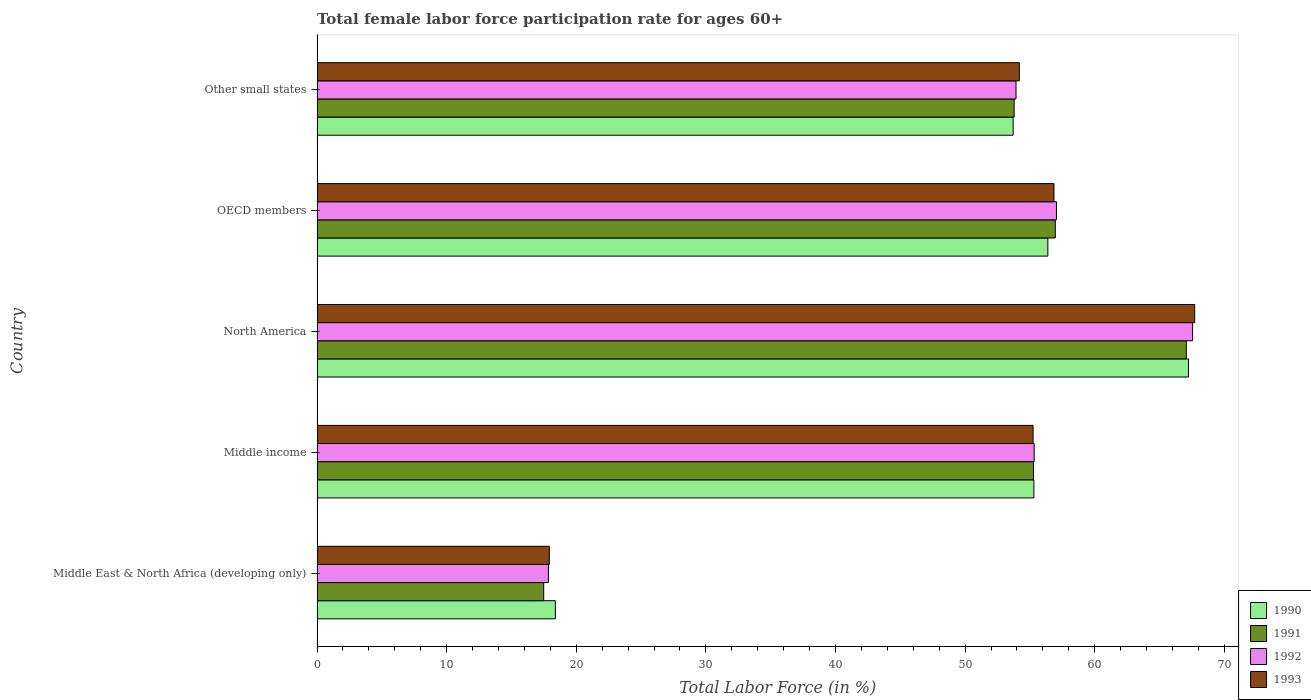How many groups of bars are there?
Keep it short and to the point. 5. How many bars are there on the 4th tick from the bottom?
Offer a terse response. 4. What is the label of the 4th group of bars from the top?
Make the answer very short. Middle income. In how many cases, is the number of bars for a given country not equal to the number of legend labels?
Give a very brief answer. 0. What is the female labor force participation rate in 1992 in Middle East & North Africa (developing only)?
Make the answer very short. 17.85. Across all countries, what is the maximum female labor force participation rate in 1990?
Provide a succinct answer. 67.23. Across all countries, what is the minimum female labor force participation rate in 1992?
Provide a succinct answer. 17.85. In which country was the female labor force participation rate in 1992 minimum?
Ensure brevity in your answer.  Middle East & North Africa (developing only). What is the total female labor force participation rate in 1991 in the graph?
Make the answer very short. 250.57. What is the difference between the female labor force participation rate in 1993 in Middle income and that in OECD members?
Your answer should be very brief. -1.61. What is the difference between the female labor force participation rate in 1991 in Middle income and the female labor force participation rate in 1990 in Middle East & North Africa (developing only)?
Your response must be concise. 36.89. What is the average female labor force participation rate in 1992 per country?
Ensure brevity in your answer.  50.34. What is the difference between the female labor force participation rate in 1990 and female labor force participation rate in 1992 in Other small states?
Your response must be concise. -0.22. In how many countries, is the female labor force participation rate in 1990 greater than 64 %?
Your response must be concise. 1. What is the ratio of the female labor force participation rate in 1993 in Middle East & North Africa (developing only) to that in Middle income?
Offer a terse response. 0.32. Is the difference between the female labor force participation rate in 1990 in Middle East & North Africa (developing only) and OECD members greater than the difference between the female labor force participation rate in 1992 in Middle East & North Africa (developing only) and OECD members?
Make the answer very short. Yes. What is the difference between the highest and the second highest female labor force participation rate in 1990?
Give a very brief answer. 10.85. What is the difference between the highest and the lowest female labor force participation rate in 1990?
Your answer should be compact. 48.85. Is the sum of the female labor force participation rate in 1990 in Middle East & North Africa (developing only) and North America greater than the maximum female labor force participation rate in 1992 across all countries?
Provide a succinct answer. Yes. What does the 1st bar from the top in Middle East & North Africa (developing only) represents?
Offer a terse response. 1993. How many countries are there in the graph?
Provide a succinct answer. 5. What is the difference between two consecutive major ticks on the X-axis?
Provide a short and direct response. 10. Does the graph contain grids?
Your response must be concise. No. Where does the legend appear in the graph?
Your response must be concise. Bottom right. How many legend labels are there?
Provide a short and direct response. 4. What is the title of the graph?
Give a very brief answer. Total female labor force participation rate for ages 60+. Does "1990" appear as one of the legend labels in the graph?
Ensure brevity in your answer.  Yes. What is the label or title of the X-axis?
Your answer should be compact. Total Labor Force (in %). What is the label or title of the Y-axis?
Your answer should be compact. Country. What is the Total Labor Force (in %) in 1990 in Middle East & North Africa (developing only)?
Ensure brevity in your answer.  18.39. What is the Total Labor Force (in %) of 1991 in Middle East & North Africa (developing only)?
Give a very brief answer. 17.49. What is the Total Labor Force (in %) of 1992 in Middle East & North Africa (developing only)?
Your response must be concise. 17.85. What is the Total Labor Force (in %) in 1993 in Middle East & North Africa (developing only)?
Provide a short and direct response. 17.92. What is the Total Labor Force (in %) in 1990 in Middle income?
Provide a short and direct response. 55.31. What is the Total Labor Force (in %) of 1991 in Middle income?
Give a very brief answer. 55.28. What is the Total Labor Force (in %) in 1992 in Middle income?
Offer a very short reply. 55.33. What is the Total Labor Force (in %) of 1993 in Middle income?
Your answer should be very brief. 55.24. What is the Total Labor Force (in %) in 1990 in North America?
Ensure brevity in your answer.  67.23. What is the Total Labor Force (in %) in 1991 in North America?
Your answer should be very brief. 67.06. What is the Total Labor Force (in %) of 1992 in North America?
Your response must be concise. 67.55. What is the Total Labor Force (in %) of 1993 in North America?
Offer a terse response. 67.71. What is the Total Labor Force (in %) of 1990 in OECD members?
Offer a terse response. 56.38. What is the Total Labor Force (in %) in 1991 in OECD members?
Provide a short and direct response. 56.96. What is the Total Labor Force (in %) in 1992 in OECD members?
Give a very brief answer. 57.05. What is the Total Labor Force (in %) in 1993 in OECD members?
Offer a terse response. 56.86. What is the Total Labor Force (in %) in 1990 in Other small states?
Make the answer very short. 53.71. What is the Total Labor Force (in %) in 1991 in Other small states?
Your answer should be very brief. 53.78. What is the Total Labor Force (in %) of 1992 in Other small states?
Your answer should be compact. 53.93. What is the Total Labor Force (in %) in 1993 in Other small states?
Ensure brevity in your answer.  54.18. Across all countries, what is the maximum Total Labor Force (in %) of 1990?
Provide a succinct answer. 67.23. Across all countries, what is the maximum Total Labor Force (in %) in 1991?
Your response must be concise. 67.06. Across all countries, what is the maximum Total Labor Force (in %) of 1992?
Your answer should be very brief. 67.55. Across all countries, what is the maximum Total Labor Force (in %) of 1993?
Your answer should be very brief. 67.71. Across all countries, what is the minimum Total Labor Force (in %) in 1990?
Your answer should be compact. 18.39. Across all countries, what is the minimum Total Labor Force (in %) in 1991?
Offer a terse response. 17.49. Across all countries, what is the minimum Total Labor Force (in %) in 1992?
Provide a short and direct response. 17.85. Across all countries, what is the minimum Total Labor Force (in %) of 1993?
Provide a short and direct response. 17.92. What is the total Total Labor Force (in %) in 1990 in the graph?
Ensure brevity in your answer.  251.01. What is the total Total Labor Force (in %) in 1991 in the graph?
Provide a succinct answer. 250.57. What is the total Total Labor Force (in %) of 1992 in the graph?
Ensure brevity in your answer.  251.7. What is the total Total Labor Force (in %) in 1993 in the graph?
Ensure brevity in your answer.  251.91. What is the difference between the Total Labor Force (in %) in 1990 in Middle East & North Africa (developing only) and that in Middle income?
Give a very brief answer. -36.92. What is the difference between the Total Labor Force (in %) in 1991 in Middle East & North Africa (developing only) and that in Middle income?
Give a very brief answer. -37.79. What is the difference between the Total Labor Force (in %) in 1992 in Middle East & North Africa (developing only) and that in Middle income?
Your answer should be very brief. -37.48. What is the difference between the Total Labor Force (in %) of 1993 in Middle East & North Africa (developing only) and that in Middle income?
Offer a very short reply. -37.32. What is the difference between the Total Labor Force (in %) in 1990 in Middle East & North Africa (developing only) and that in North America?
Your answer should be compact. -48.85. What is the difference between the Total Labor Force (in %) of 1991 in Middle East & North Africa (developing only) and that in North America?
Make the answer very short. -49.58. What is the difference between the Total Labor Force (in %) of 1992 in Middle East & North Africa (developing only) and that in North America?
Make the answer very short. -49.7. What is the difference between the Total Labor Force (in %) in 1993 in Middle East & North Africa (developing only) and that in North America?
Give a very brief answer. -49.79. What is the difference between the Total Labor Force (in %) in 1990 in Middle East & North Africa (developing only) and that in OECD members?
Your answer should be compact. -38. What is the difference between the Total Labor Force (in %) in 1991 in Middle East & North Africa (developing only) and that in OECD members?
Offer a very short reply. -39.47. What is the difference between the Total Labor Force (in %) in 1992 in Middle East & North Africa (developing only) and that in OECD members?
Your response must be concise. -39.2. What is the difference between the Total Labor Force (in %) of 1993 in Middle East & North Africa (developing only) and that in OECD members?
Offer a terse response. -38.94. What is the difference between the Total Labor Force (in %) in 1990 in Middle East & North Africa (developing only) and that in Other small states?
Offer a very short reply. -35.32. What is the difference between the Total Labor Force (in %) in 1991 in Middle East & North Africa (developing only) and that in Other small states?
Provide a short and direct response. -36.3. What is the difference between the Total Labor Force (in %) of 1992 in Middle East & North Africa (developing only) and that in Other small states?
Offer a terse response. -36.08. What is the difference between the Total Labor Force (in %) of 1993 in Middle East & North Africa (developing only) and that in Other small states?
Your response must be concise. -36.26. What is the difference between the Total Labor Force (in %) of 1990 in Middle income and that in North America?
Provide a short and direct response. -11.93. What is the difference between the Total Labor Force (in %) in 1991 in Middle income and that in North America?
Your answer should be very brief. -11.79. What is the difference between the Total Labor Force (in %) of 1992 in Middle income and that in North America?
Your response must be concise. -12.23. What is the difference between the Total Labor Force (in %) in 1993 in Middle income and that in North America?
Your answer should be very brief. -12.47. What is the difference between the Total Labor Force (in %) in 1990 in Middle income and that in OECD members?
Make the answer very short. -1.08. What is the difference between the Total Labor Force (in %) in 1991 in Middle income and that in OECD members?
Provide a short and direct response. -1.68. What is the difference between the Total Labor Force (in %) of 1992 in Middle income and that in OECD members?
Your response must be concise. -1.72. What is the difference between the Total Labor Force (in %) in 1993 in Middle income and that in OECD members?
Ensure brevity in your answer.  -1.61. What is the difference between the Total Labor Force (in %) in 1990 in Middle income and that in Other small states?
Your answer should be compact. 1.6. What is the difference between the Total Labor Force (in %) in 1991 in Middle income and that in Other small states?
Your answer should be compact. 1.5. What is the difference between the Total Labor Force (in %) in 1992 in Middle income and that in Other small states?
Provide a short and direct response. 1.4. What is the difference between the Total Labor Force (in %) in 1993 in Middle income and that in Other small states?
Provide a succinct answer. 1.06. What is the difference between the Total Labor Force (in %) in 1990 in North America and that in OECD members?
Your answer should be very brief. 10.85. What is the difference between the Total Labor Force (in %) of 1991 in North America and that in OECD members?
Your answer should be compact. 10.11. What is the difference between the Total Labor Force (in %) in 1992 in North America and that in OECD members?
Ensure brevity in your answer.  10.51. What is the difference between the Total Labor Force (in %) of 1993 in North America and that in OECD members?
Your answer should be compact. 10.85. What is the difference between the Total Labor Force (in %) in 1990 in North America and that in Other small states?
Offer a very short reply. 13.53. What is the difference between the Total Labor Force (in %) of 1991 in North America and that in Other small states?
Ensure brevity in your answer.  13.28. What is the difference between the Total Labor Force (in %) in 1992 in North America and that in Other small states?
Keep it short and to the point. 13.62. What is the difference between the Total Labor Force (in %) in 1993 in North America and that in Other small states?
Your response must be concise. 13.53. What is the difference between the Total Labor Force (in %) of 1990 in OECD members and that in Other small states?
Offer a very short reply. 2.68. What is the difference between the Total Labor Force (in %) of 1991 in OECD members and that in Other small states?
Your answer should be very brief. 3.17. What is the difference between the Total Labor Force (in %) in 1992 in OECD members and that in Other small states?
Your answer should be compact. 3.12. What is the difference between the Total Labor Force (in %) of 1993 in OECD members and that in Other small states?
Offer a terse response. 2.67. What is the difference between the Total Labor Force (in %) of 1990 in Middle East & North Africa (developing only) and the Total Labor Force (in %) of 1991 in Middle income?
Provide a succinct answer. -36.89. What is the difference between the Total Labor Force (in %) in 1990 in Middle East & North Africa (developing only) and the Total Labor Force (in %) in 1992 in Middle income?
Ensure brevity in your answer.  -36.94. What is the difference between the Total Labor Force (in %) of 1990 in Middle East & North Africa (developing only) and the Total Labor Force (in %) of 1993 in Middle income?
Provide a short and direct response. -36.86. What is the difference between the Total Labor Force (in %) of 1991 in Middle East & North Africa (developing only) and the Total Labor Force (in %) of 1992 in Middle income?
Keep it short and to the point. -37.84. What is the difference between the Total Labor Force (in %) in 1991 in Middle East & North Africa (developing only) and the Total Labor Force (in %) in 1993 in Middle income?
Provide a short and direct response. -37.76. What is the difference between the Total Labor Force (in %) in 1992 in Middle East & North Africa (developing only) and the Total Labor Force (in %) in 1993 in Middle income?
Provide a succinct answer. -37.39. What is the difference between the Total Labor Force (in %) in 1990 in Middle East & North Africa (developing only) and the Total Labor Force (in %) in 1991 in North America?
Provide a succinct answer. -48.68. What is the difference between the Total Labor Force (in %) in 1990 in Middle East & North Africa (developing only) and the Total Labor Force (in %) in 1992 in North America?
Your answer should be very brief. -49.16. What is the difference between the Total Labor Force (in %) in 1990 in Middle East & North Africa (developing only) and the Total Labor Force (in %) in 1993 in North America?
Offer a very short reply. -49.32. What is the difference between the Total Labor Force (in %) of 1991 in Middle East & North Africa (developing only) and the Total Labor Force (in %) of 1992 in North America?
Provide a succinct answer. -50.06. What is the difference between the Total Labor Force (in %) of 1991 in Middle East & North Africa (developing only) and the Total Labor Force (in %) of 1993 in North America?
Offer a terse response. -50.22. What is the difference between the Total Labor Force (in %) of 1992 in Middle East & North Africa (developing only) and the Total Labor Force (in %) of 1993 in North America?
Ensure brevity in your answer.  -49.86. What is the difference between the Total Labor Force (in %) in 1990 in Middle East & North Africa (developing only) and the Total Labor Force (in %) in 1991 in OECD members?
Provide a succinct answer. -38.57. What is the difference between the Total Labor Force (in %) of 1990 in Middle East & North Africa (developing only) and the Total Labor Force (in %) of 1992 in OECD members?
Your answer should be compact. -38.66. What is the difference between the Total Labor Force (in %) in 1990 in Middle East & North Africa (developing only) and the Total Labor Force (in %) in 1993 in OECD members?
Give a very brief answer. -38.47. What is the difference between the Total Labor Force (in %) in 1991 in Middle East & North Africa (developing only) and the Total Labor Force (in %) in 1992 in OECD members?
Make the answer very short. -39.56. What is the difference between the Total Labor Force (in %) of 1991 in Middle East & North Africa (developing only) and the Total Labor Force (in %) of 1993 in OECD members?
Offer a terse response. -39.37. What is the difference between the Total Labor Force (in %) of 1992 in Middle East & North Africa (developing only) and the Total Labor Force (in %) of 1993 in OECD members?
Your answer should be very brief. -39.01. What is the difference between the Total Labor Force (in %) of 1990 in Middle East & North Africa (developing only) and the Total Labor Force (in %) of 1991 in Other small states?
Ensure brevity in your answer.  -35.4. What is the difference between the Total Labor Force (in %) in 1990 in Middle East & North Africa (developing only) and the Total Labor Force (in %) in 1992 in Other small states?
Your response must be concise. -35.54. What is the difference between the Total Labor Force (in %) of 1990 in Middle East & North Africa (developing only) and the Total Labor Force (in %) of 1993 in Other small states?
Provide a short and direct response. -35.8. What is the difference between the Total Labor Force (in %) in 1991 in Middle East & North Africa (developing only) and the Total Labor Force (in %) in 1992 in Other small states?
Provide a short and direct response. -36.44. What is the difference between the Total Labor Force (in %) in 1991 in Middle East & North Africa (developing only) and the Total Labor Force (in %) in 1993 in Other small states?
Provide a short and direct response. -36.7. What is the difference between the Total Labor Force (in %) of 1992 in Middle East & North Africa (developing only) and the Total Labor Force (in %) of 1993 in Other small states?
Offer a terse response. -36.33. What is the difference between the Total Labor Force (in %) of 1990 in Middle income and the Total Labor Force (in %) of 1991 in North America?
Provide a succinct answer. -11.76. What is the difference between the Total Labor Force (in %) in 1990 in Middle income and the Total Labor Force (in %) in 1992 in North America?
Provide a short and direct response. -12.25. What is the difference between the Total Labor Force (in %) of 1990 in Middle income and the Total Labor Force (in %) of 1993 in North America?
Ensure brevity in your answer.  -12.4. What is the difference between the Total Labor Force (in %) in 1991 in Middle income and the Total Labor Force (in %) in 1992 in North America?
Offer a very short reply. -12.27. What is the difference between the Total Labor Force (in %) in 1991 in Middle income and the Total Labor Force (in %) in 1993 in North America?
Your answer should be compact. -12.43. What is the difference between the Total Labor Force (in %) in 1992 in Middle income and the Total Labor Force (in %) in 1993 in North America?
Your response must be concise. -12.38. What is the difference between the Total Labor Force (in %) in 1990 in Middle income and the Total Labor Force (in %) in 1991 in OECD members?
Offer a terse response. -1.65. What is the difference between the Total Labor Force (in %) in 1990 in Middle income and the Total Labor Force (in %) in 1992 in OECD members?
Your answer should be compact. -1.74. What is the difference between the Total Labor Force (in %) in 1990 in Middle income and the Total Labor Force (in %) in 1993 in OECD members?
Keep it short and to the point. -1.55. What is the difference between the Total Labor Force (in %) in 1991 in Middle income and the Total Labor Force (in %) in 1992 in OECD members?
Your answer should be compact. -1.77. What is the difference between the Total Labor Force (in %) of 1991 in Middle income and the Total Labor Force (in %) of 1993 in OECD members?
Make the answer very short. -1.58. What is the difference between the Total Labor Force (in %) of 1992 in Middle income and the Total Labor Force (in %) of 1993 in OECD members?
Give a very brief answer. -1.53. What is the difference between the Total Labor Force (in %) in 1990 in Middle income and the Total Labor Force (in %) in 1991 in Other small states?
Keep it short and to the point. 1.52. What is the difference between the Total Labor Force (in %) of 1990 in Middle income and the Total Labor Force (in %) of 1992 in Other small states?
Provide a succinct answer. 1.38. What is the difference between the Total Labor Force (in %) of 1990 in Middle income and the Total Labor Force (in %) of 1993 in Other small states?
Offer a very short reply. 1.12. What is the difference between the Total Labor Force (in %) in 1991 in Middle income and the Total Labor Force (in %) in 1992 in Other small states?
Your response must be concise. 1.35. What is the difference between the Total Labor Force (in %) of 1991 in Middle income and the Total Labor Force (in %) of 1993 in Other small states?
Your answer should be compact. 1.1. What is the difference between the Total Labor Force (in %) in 1992 in Middle income and the Total Labor Force (in %) in 1993 in Other small states?
Make the answer very short. 1.14. What is the difference between the Total Labor Force (in %) in 1990 in North America and the Total Labor Force (in %) in 1991 in OECD members?
Ensure brevity in your answer.  10.28. What is the difference between the Total Labor Force (in %) of 1990 in North America and the Total Labor Force (in %) of 1992 in OECD members?
Give a very brief answer. 10.19. What is the difference between the Total Labor Force (in %) in 1990 in North America and the Total Labor Force (in %) in 1993 in OECD members?
Offer a very short reply. 10.38. What is the difference between the Total Labor Force (in %) in 1991 in North America and the Total Labor Force (in %) in 1992 in OECD members?
Give a very brief answer. 10.02. What is the difference between the Total Labor Force (in %) in 1991 in North America and the Total Labor Force (in %) in 1993 in OECD members?
Provide a short and direct response. 10.21. What is the difference between the Total Labor Force (in %) of 1992 in North America and the Total Labor Force (in %) of 1993 in OECD members?
Provide a short and direct response. 10.7. What is the difference between the Total Labor Force (in %) of 1990 in North America and the Total Labor Force (in %) of 1991 in Other small states?
Keep it short and to the point. 13.45. What is the difference between the Total Labor Force (in %) of 1990 in North America and the Total Labor Force (in %) of 1992 in Other small states?
Offer a terse response. 13.31. What is the difference between the Total Labor Force (in %) of 1990 in North America and the Total Labor Force (in %) of 1993 in Other small states?
Provide a succinct answer. 13.05. What is the difference between the Total Labor Force (in %) in 1991 in North America and the Total Labor Force (in %) in 1992 in Other small states?
Offer a very short reply. 13.14. What is the difference between the Total Labor Force (in %) in 1991 in North America and the Total Labor Force (in %) in 1993 in Other small states?
Offer a very short reply. 12.88. What is the difference between the Total Labor Force (in %) of 1992 in North America and the Total Labor Force (in %) of 1993 in Other small states?
Provide a succinct answer. 13.37. What is the difference between the Total Labor Force (in %) in 1990 in OECD members and the Total Labor Force (in %) in 1991 in Other small states?
Your answer should be compact. 2.6. What is the difference between the Total Labor Force (in %) in 1990 in OECD members and the Total Labor Force (in %) in 1992 in Other small states?
Provide a succinct answer. 2.45. What is the difference between the Total Labor Force (in %) of 1990 in OECD members and the Total Labor Force (in %) of 1993 in Other small states?
Your response must be concise. 2.2. What is the difference between the Total Labor Force (in %) in 1991 in OECD members and the Total Labor Force (in %) in 1992 in Other small states?
Give a very brief answer. 3.03. What is the difference between the Total Labor Force (in %) of 1991 in OECD members and the Total Labor Force (in %) of 1993 in Other small states?
Ensure brevity in your answer.  2.78. What is the difference between the Total Labor Force (in %) in 1992 in OECD members and the Total Labor Force (in %) in 1993 in Other small states?
Your answer should be compact. 2.86. What is the average Total Labor Force (in %) of 1990 per country?
Your answer should be very brief. 50.2. What is the average Total Labor Force (in %) in 1991 per country?
Give a very brief answer. 50.11. What is the average Total Labor Force (in %) of 1992 per country?
Keep it short and to the point. 50.34. What is the average Total Labor Force (in %) of 1993 per country?
Provide a short and direct response. 50.38. What is the difference between the Total Labor Force (in %) in 1990 and Total Labor Force (in %) in 1991 in Middle East & North Africa (developing only)?
Your answer should be very brief. 0.9. What is the difference between the Total Labor Force (in %) in 1990 and Total Labor Force (in %) in 1992 in Middle East & North Africa (developing only)?
Ensure brevity in your answer.  0.54. What is the difference between the Total Labor Force (in %) of 1990 and Total Labor Force (in %) of 1993 in Middle East & North Africa (developing only)?
Your answer should be very brief. 0.47. What is the difference between the Total Labor Force (in %) of 1991 and Total Labor Force (in %) of 1992 in Middle East & North Africa (developing only)?
Your answer should be compact. -0.36. What is the difference between the Total Labor Force (in %) in 1991 and Total Labor Force (in %) in 1993 in Middle East & North Africa (developing only)?
Keep it short and to the point. -0.43. What is the difference between the Total Labor Force (in %) in 1992 and Total Labor Force (in %) in 1993 in Middle East & North Africa (developing only)?
Offer a terse response. -0.07. What is the difference between the Total Labor Force (in %) in 1990 and Total Labor Force (in %) in 1991 in Middle income?
Provide a succinct answer. 0.03. What is the difference between the Total Labor Force (in %) of 1990 and Total Labor Force (in %) of 1992 in Middle income?
Your response must be concise. -0.02. What is the difference between the Total Labor Force (in %) in 1990 and Total Labor Force (in %) in 1993 in Middle income?
Offer a terse response. 0.06. What is the difference between the Total Labor Force (in %) of 1991 and Total Labor Force (in %) of 1992 in Middle income?
Your answer should be very brief. -0.05. What is the difference between the Total Labor Force (in %) of 1991 and Total Labor Force (in %) of 1993 in Middle income?
Offer a terse response. 0.03. What is the difference between the Total Labor Force (in %) in 1992 and Total Labor Force (in %) in 1993 in Middle income?
Make the answer very short. 0.08. What is the difference between the Total Labor Force (in %) in 1990 and Total Labor Force (in %) in 1991 in North America?
Provide a short and direct response. 0.17. What is the difference between the Total Labor Force (in %) in 1990 and Total Labor Force (in %) in 1992 in North America?
Your answer should be very brief. -0.32. What is the difference between the Total Labor Force (in %) of 1990 and Total Labor Force (in %) of 1993 in North America?
Your answer should be compact. -0.48. What is the difference between the Total Labor Force (in %) of 1991 and Total Labor Force (in %) of 1992 in North America?
Your response must be concise. -0.49. What is the difference between the Total Labor Force (in %) of 1991 and Total Labor Force (in %) of 1993 in North America?
Your answer should be compact. -0.65. What is the difference between the Total Labor Force (in %) in 1992 and Total Labor Force (in %) in 1993 in North America?
Ensure brevity in your answer.  -0.16. What is the difference between the Total Labor Force (in %) of 1990 and Total Labor Force (in %) of 1991 in OECD members?
Give a very brief answer. -0.58. What is the difference between the Total Labor Force (in %) in 1990 and Total Labor Force (in %) in 1992 in OECD members?
Offer a terse response. -0.66. What is the difference between the Total Labor Force (in %) of 1990 and Total Labor Force (in %) of 1993 in OECD members?
Keep it short and to the point. -0.47. What is the difference between the Total Labor Force (in %) in 1991 and Total Labor Force (in %) in 1992 in OECD members?
Provide a succinct answer. -0.09. What is the difference between the Total Labor Force (in %) of 1991 and Total Labor Force (in %) of 1993 in OECD members?
Your answer should be compact. 0.1. What is the difference between the Total Labor Force (in %) of 1992 and Total Labor Force (in %) of 1993 in OECD members?
Provide a short and direct response. 0.19. What is the difference between the Total Labor Force (in %) in 1990 and Total Labor Force (in %) in 1991 in Other small states?
Make the answer very short. -0.08. What is the difference between the Total Labor Force (in %) in 1990 and Total Labor Force (in %) in 1992 in Other small states?
Provide a succinct answer. -0.22. What is the difference between the Total Labor Force (in %) in 1990 and Total Labor Force (in %) in 1993 in Other small states?
Make the answer very short. -0.48. What is the difference between the Total Labor Force (in %) in 1991 and Total Labor Force (in %) in 1992 in Other small states?
Make the answer very short. -0.14. What is the difference between the Total Labor Force (in %) in 1991 and Total Labor Force (in %) in 1993 in Other small states?
Make the answer very short. -0.4. What is the difference between the Total Labor Force (in %) in 1992 and Total Labor Force (in %) in 1993 in Other small states?
Give a very brief answer. -0.25. What is the ratio of the Total Labor Force (in %) in 1990 in Middle East & North Africa (developing only) to that in Middle income?
Your answer should be very brief. 0.33. What is the ratio of the Total Labor Force (in %) in 1991 in Middle East & North Africa (developing only) to that in Middle income?
Offer a terse response. 0.32. What is the ratio of the Total Labor Force (in %) in 1992 in Middle East & North Africa (developing only) to that in Middle income?
Make the answer very short. 0.32. What is the ratio of the Total Labor Force (in %) of 1993 in Middle East & North Africa (developing only) to that in Middle income?
Make the answer very short. 0.32. What is the ratio of the Total Labor Force (in %) of 1990 in Middle East & North Africa (developing only) to that in North America?
Provide a short and direct response. 0.27. What is the ratio of the Total Labor Force (in %) of 1991 in Middle East & North Africa (developing only) to that in North America?
Provide a succinct answer. 0.26. What is the ratio of the Total Labor Force (in %) in 1992 in Middle East & North Africa (developing only) to that in North America?
Your answer should be very brief. 0.26. What is the ratio of the Total Labor Force (in %) in 1993 in Middle East & North Africa (developing only) to that in North America?
Your answer should be compact. 0.26. What is the ratio of the Total Labor Force (in %) in 1990 in Middle East & North Africa (developing only) to that in OECD members?
Your answer should be compact. 0.33. What is the ratio of the Total Labor Force (in %) of 1991 in Middle East & North Africa (developing only) to that in OECD members?
Offer a very short reply. 0.31. What is the ratio of the Total Labor Force (in %) in 1992 in Middle East & North Africa (developing only) to that in OECD members?
Offer a terse response. 0.31. What is the ratio of the Total Labor Force (in %) of 1993 in Middle East & North Africa (developing only) to that in OECD members?
Provide a succinct answer. 0.32. What is the ratio of the Total Labor Force (in %) of 1990 in Middle East & North Africa (developing only) to that in Other small states?
Ensure brevity in your answer.  0.34. What is the ratio of the Total Labor Force (in %) in 1991 in Middle East & North Africa (developing only) to that in Other small states?
Provide a short and direct response. 0.33. What is the ratio of the Total Labor Force (in %) of 1992 in Middle East & North Africa (developing only) to that in Other small states?
Keep it short and to the point. 0.33. What is the ratio of the Total Labor Force (in %) of 1993 in Middle East & North Africa (developing only) to that in Other small states?
Your answer should be very brief. 0.33. What is the ratio of the Total Labor Force (in %) in 1990 in Middle income to that in North America?
Your answer should be compact. 0.82. What is the ratio of the Total Labor Force (in %) of 1991 in Middle income to that in North America?
Offer a terse response. 0.82. What is the ratio of the Total Labor Force (in %) of 1992 in Middle income to that in North America?
Provide a succinct answer. 0.82. What is the ratio of the Total Labor Force (in %) of 1993 in Middle income to that in North America?
Keep it short and to the point. 0.82. What is the ratio of the Total Labor Force (in %) of 1990 in Middle income to that in OECD members?
Give a very brief answer. 0.98. What is the ratio of the Total Labor Force (in %) in 1991 in Middle income to that in OECD members?
Offer a terse response. 0.97. What is the ratio of the Total Labor Force (in %) in 1992 in Middle income to that in OECD members?
Make the answer very short. 0.97. What is the ratio of the Total Labor Force (in %) in 1993 in Middle income to that in OECD members?
Your answer should be very brief. 0.97. What is the ratio of the Total Labor Force (in %) in 1990 in Middle income to that in Other small states?
Your answer should be compact. 1.03. What is the ratio of the Total Labor Force (in %) in 1991 in Middle income to that in Other small states?
Provide a short and direct response. 1.03. What is the ratio of the Total Labor Force (in %) in 1992 in Middle income to that in Other small states?
Offer a very short reply. 1.03. What is the ratio of the Total Labor Force (in %) in 1993 in Middle income to that in Other small states?
Provide a succinct answer. 1.02. What is the ratio of the Total Labor Force (in %) of 1990 in North America to that in OECD members?
Your answer should be compact. 1.19. What is the ratio of the Total Labor Force (in %) in 1991 in North America to that in OECD members?
Ensure brevity in your answer.  1.18. What is the ratio of the Total Labor Force (in %) of 1992 in North America to that in OECD members?
Provide a short and direct response. 1.18. What is the ratio of the Total Labor Force (in %) in 1993 in North America to that in OECD members?
Provide a succinct answer. 1.19. What is the ratio of the Total Labor Force (in %) of 1990 in North America to that in Other small states?
Make the answer very short. 1.25. What is the ratio of the Total Labor Force (in %) of 1991 in North America to that in Other small states?
Give a very brief answer. 1.25. What is the ratio of the Total Labor Force (in %) of 1992 in North America to that in Other small states?
Provide a short and direct response. 1.25. What is the ratio of the Total Labor Force (in %) of 1993 in North America to that in Other small states?
Offer a terse response. 1.25. What is the ratio of the Total Labor Force (in %) in 1990 in OECD members to that in Other small states?
Your response must be concise. 1.05. What is the ratio of the Total Labor Force (in %) of 1991 in OECD members to that in Other small states?
Make the answer very short. 1.06. What is the ratio of the Total Labor Force (in %) in 1992 in OECD members to that in Other small states?
Offer a very short reply. 1.06. What is the ratio of the Total Labor Force (in %) of 1993 in OECD members to that in Other small states?
Provide a short and direct response. 1.05. What is the difference between the highest and the second highest Total Labor Force (in %) of 1990?
Your response must be concise. 10.85. What is the difference between the highest and the second highest Total Labor Force (in %) in 1991?
Offer a very short reply. 10.11. What is the difference between the highest and the second highest Total Labor Force (in %) in 1992?
Make the answer very short. 10.51. What is the difference between the highest and the second highest Total Labor Force (in %) of 1993?
Your answer should be compact. 10.85. What is the difference between the highest and the lowest Total Labor Force (in %) of 1990?
Make the answer very short. 48.85. What is the difference between the highest and the lowest Total Labor Force (in %) of 1991?
Make the answer very short. 49.58. What is the difference between the highest and the lowest Total Labor Force (in %) of 1992?
Make the answer very short. 49.7. What is the difference between the highest and the lowest Total Labor Force (in %) of 1993?
Keep it short and to the point. 49.79. 